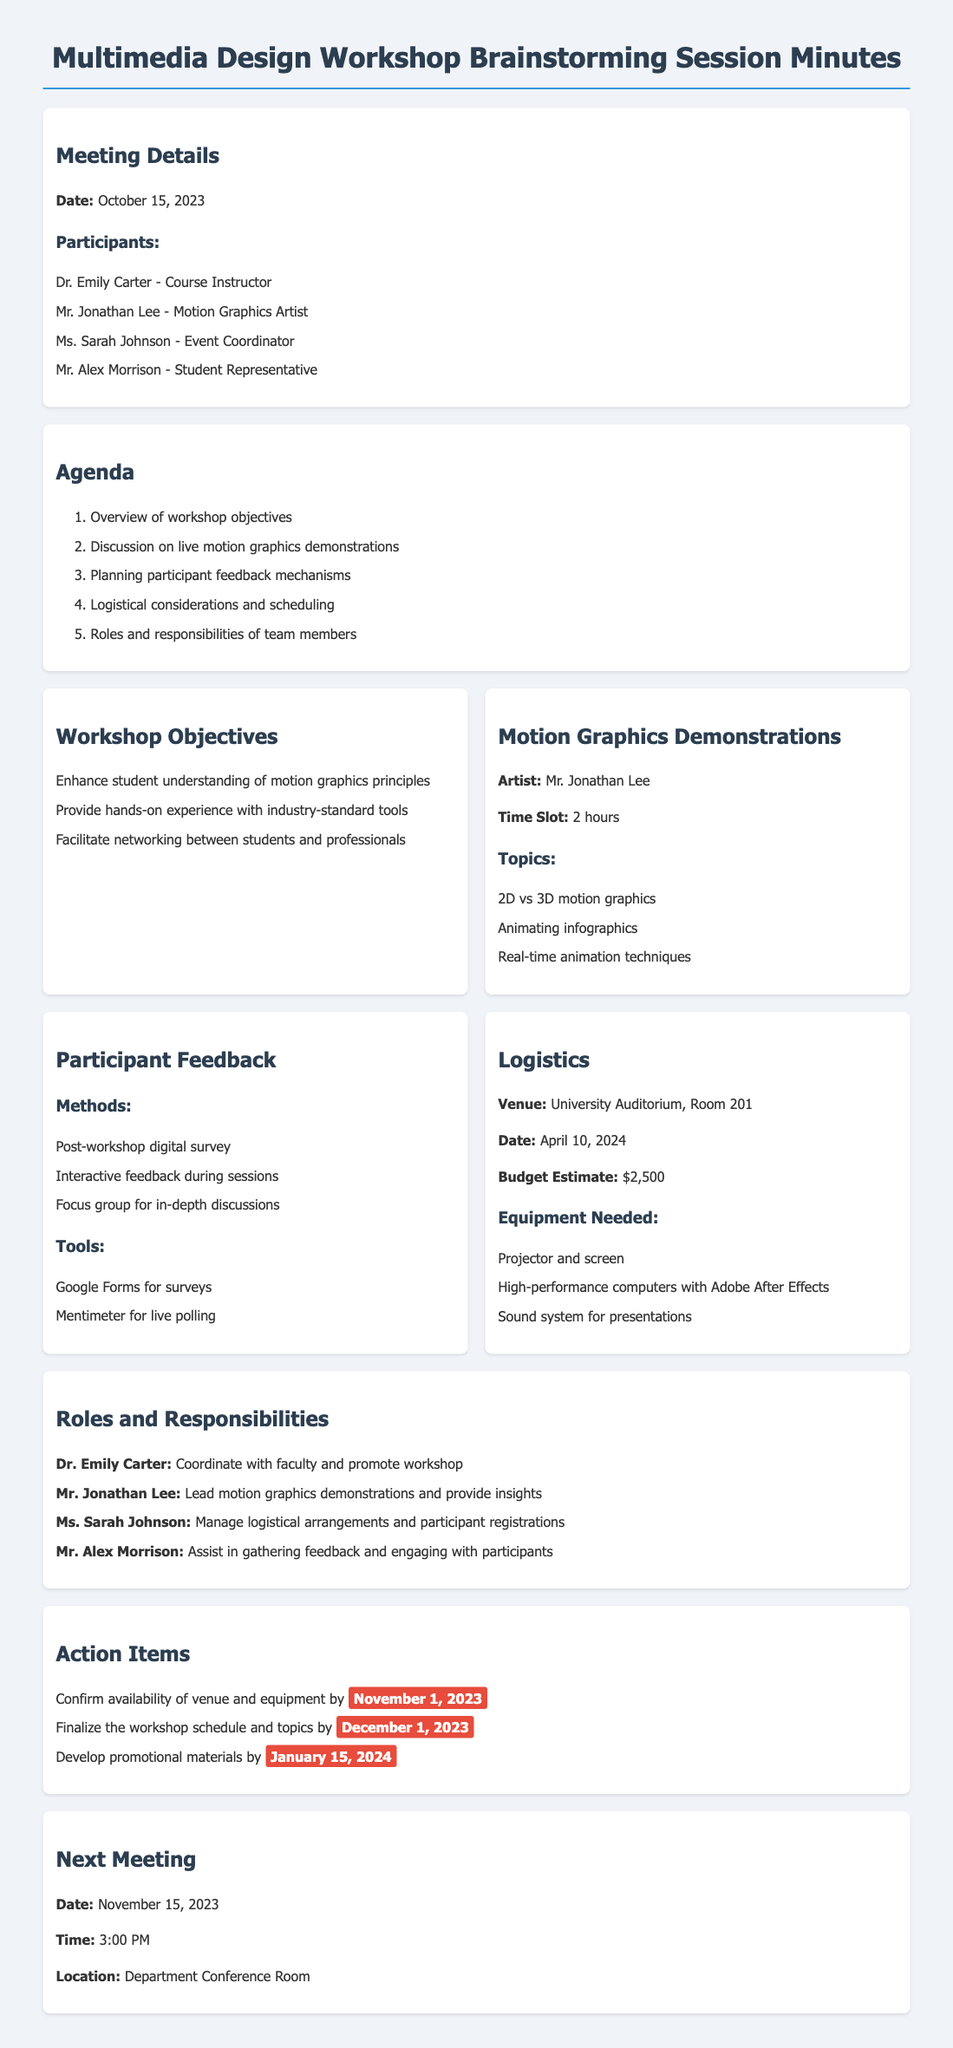What is the date of the workshop? The date of the workshop is specified in the logistics section of the document.
Answer: April 10, 2024 Who is the motion graphics artist featured in the workshop? This information can be found in the motion graphics demonstrations section, listing the artist's name.
Answer: Mr. Jonathan Lee What budget estimate is provided for the workshop? The budget estimate is explicitly stated in the logistics section.
Answer: $2,500 What methods will be used for participant feedback? The feedback methods listed in the participant feedback section include various approaches to gather insights from participants.
Answer: Post-workshop digital survey What role does Ms. Sarah Johnson have in the workshop organization? The roles and responsibilities section outlines Ms. Sarah Johnson's specific duties.
Answer: Manage logistical arrangements and participant registrations Which date is set for the next meeting? The subsequent meeting date is found in the next meeting section of the document.
Answer: November 15, 2023 What is the time slot allocated for the motion graphics demonstrations? The time slot for the demonstrations is mentioned in the motion graphics demonstrations section.
Answer: 2 hours What are the three topics covered in the motion graphics demonstrations? The topics are listed in a bullet format under the motion graphics demonstrations section.
Answer: 2D vs 3D motion graphics, Animating infographics, Real-time animation techniques 